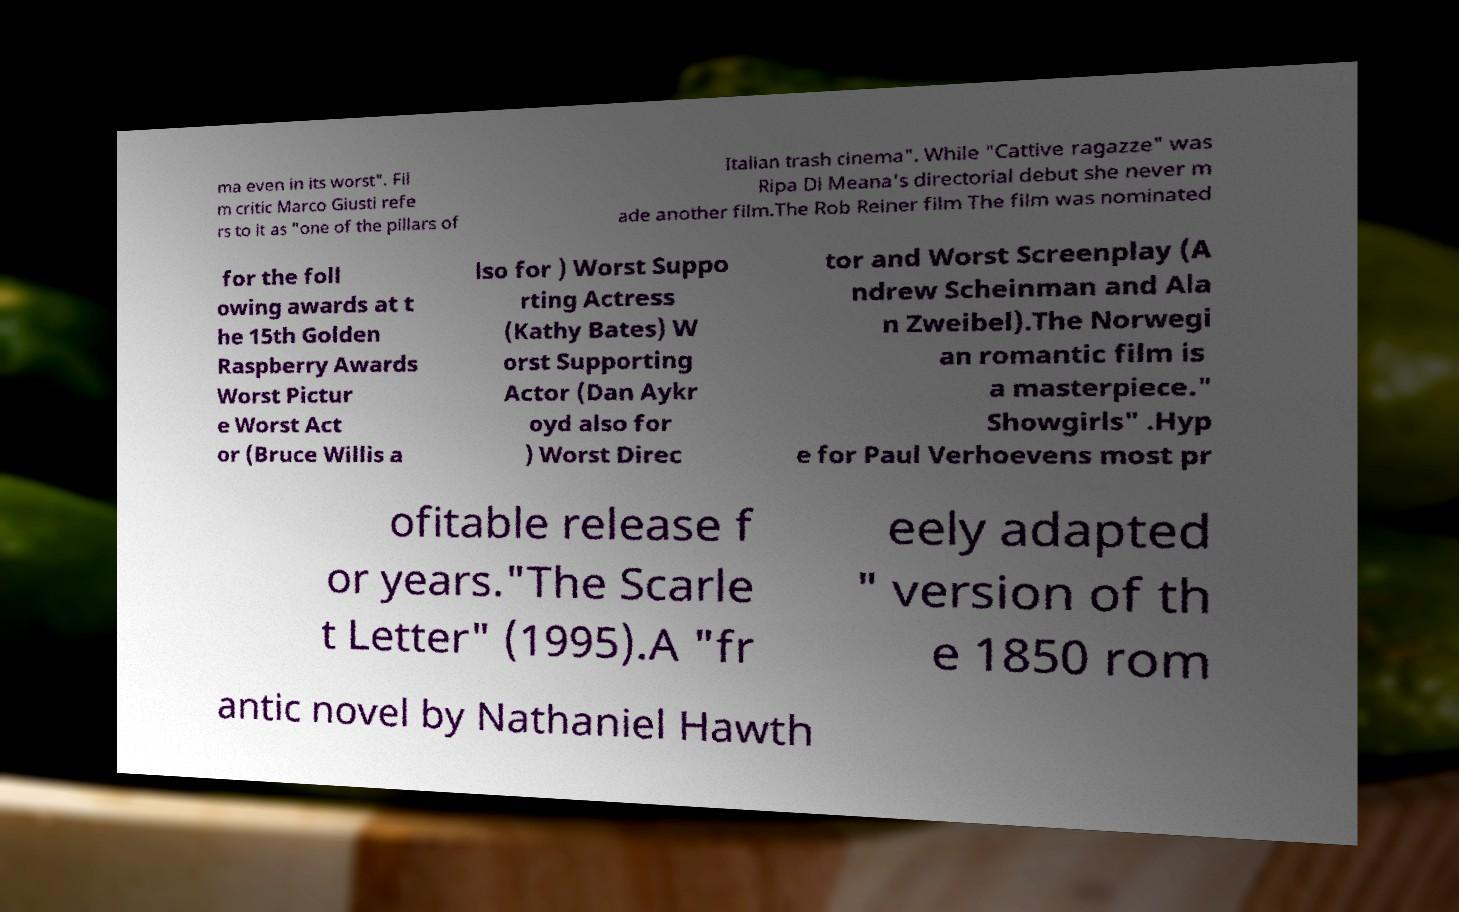Could you assist in decoding the text presented in this image and type it out clearly? ma even in its worst". Fil m critic Marco Giusti refe rs to it as "one of the pillars of Italian trash cinema". While "Cattive ragazze" was Ripa Di Meana's directorial debut she never m ade another film.The Rob Reiner film The film was nominated for the foll owing awards at t he 15th Golden Raspberry Awards Worst Pictur e Worst Act or (Bruce Willis a lso for ) Worst Suppo rting Actress (Kathy Bates) W orst Supporting Actor (Dan Aykr oyd also for ) Worst Direc tor and Worst Screenplay (A ndrew Scheinman and Ala n Zweibel).The Norwegi an romantic film is a masterpiece." Showgirls" .Hyp e for Paul Verhoevens most pr ofitable release f or years."The Scarle t Letter" (1995).A "fr eely adapted " version of th e 1850 rom antic novel by Nathaniel Hawth 